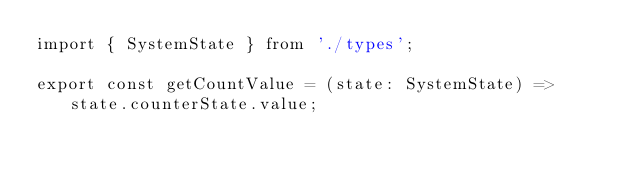Convert code to text. <code><loc_0><loc_0><loc_500><loc_500><_TypeScript_>import { SystemState } from './types';

export const getCountValue = (state: SystemState) => state.counterState.value;
</code> 